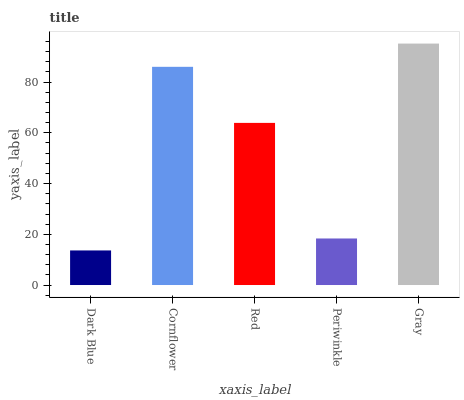Is Dark Blue the minimum?
Answer yes or no. Yes. Is Gray the maximum?
Answer yes or no. Yes. Is Cornflower the minimum?
Answer yes or no. No. Is Cornflower the maximum?
Answer yes or no. No. Is Cornflower greater than Dark Blue?
Answer yes or no. Yes. Is Dark Blue less than Cornflower?
Answer yes or no. Yes. Is Dark Blue greater than Cornflower?
Answer yes or no. No. Is Cornflower less than Dark Blue?
Answer yes or no. No. Is Red the high median?
Answer yes or no. Yes. Is Red the low median?
Answer yes or no. Yes. Is Periwinkle the high median?
Answer yes or no. No. Is Dark Blue the low median?
Answer yes or no. No. 